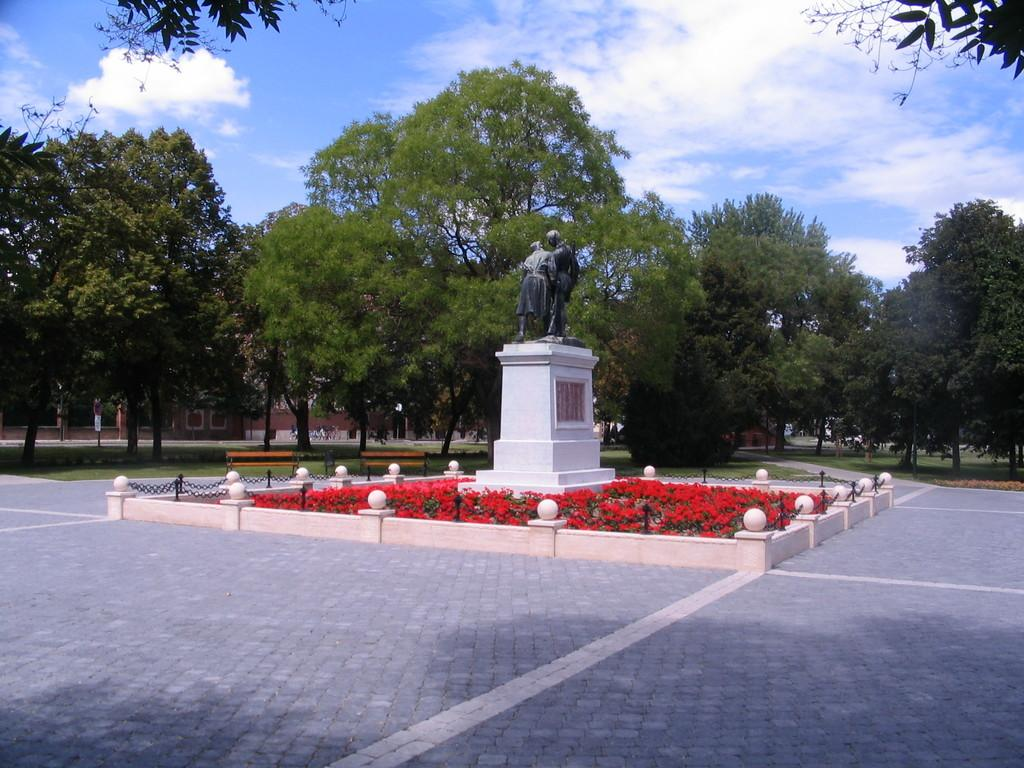What types of plants can be seen in the image? There are flowers in the image. What other objects are present in the image? There are bulbs and a memorial stone with a statue on it. What can be seen in the background of the image? There is a building, trees, and the sky visible in the background of the image. What is the condition of the sky in the image? The sky is visible in the background of the image, and there are clouds present. What type of feather can be seen on the statue in the image? There is no feather present on the statue in the image. What religion is represented by the statue in the image? The image does not provide any information about the religion represented by the statue. 